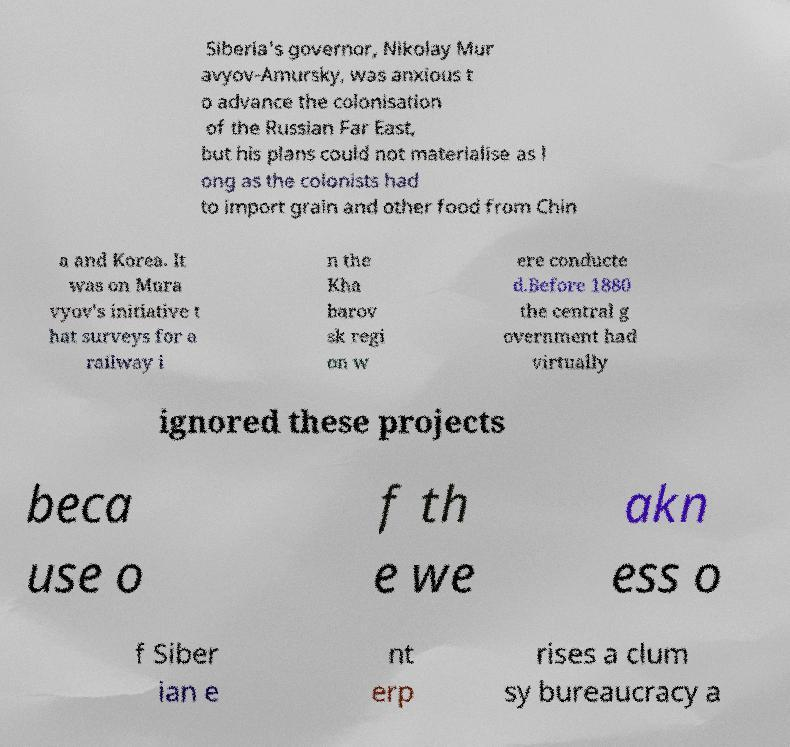Please identify and transcribe the text found in this image. Siberia's governor, Nikolay Mur avyov-Amursky, was anxious t o advance the colonisation of the Russian Far East, but his plans could not materialise as l ong as the colonists had to import grain and other food from Chin a and Korea. It was on Mura vyov's initiative t hat surveys for a railway i n the Kha barov sk regi on w ere conducte d.Before 1880 the central g overnment had virtually ignored these projects beca use o f th e we akn ess o f Siber ian e nt erp rises a clum sy bureaucracy a 